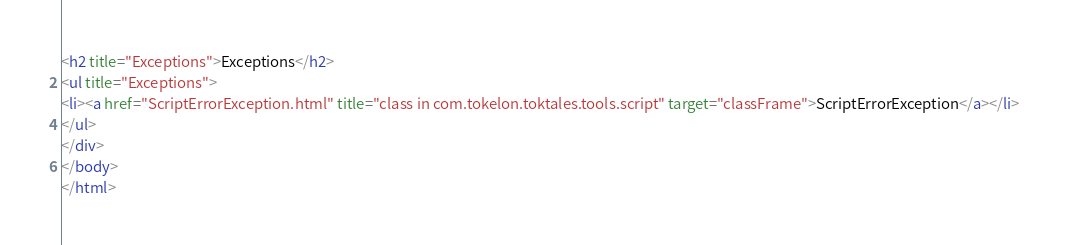<code> <loc_0><loc_0><loc_500><loc_500><_HTML_><h2 title="Exceptions">Exceptions</h2>
<ul title="Exceptions">
<li><a href="ScriptErrorException.html" title="class in com.tokelon.toktales.tools.script" target="classFrame">ScriptErrorException</a></li>
</ul>
</div>
</body>
</html>
</code> 